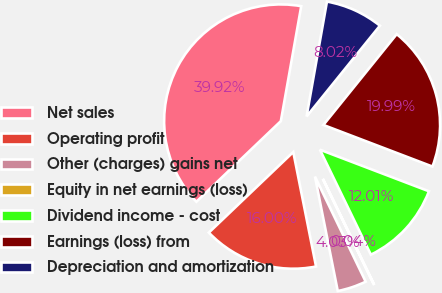Convert chart. <chart><loc_0><loc_0><loc_500><loc_500><pie_chart><fcel>Net sales<fcel>Operating profit<fcel>Other (charges) gains net<fcel>Equity in net earnings (loss)<fcel>Dividend income - cost<fcel>Earnings (loss) from<fcel>Depreciation and amortization<nl><fcel>39.93%<fcel>16.0%<fcel>4.03%<fcel>0.04%<fcel>12.01%<fcel>19.99%<fcel>8.02%<nl></chart> 